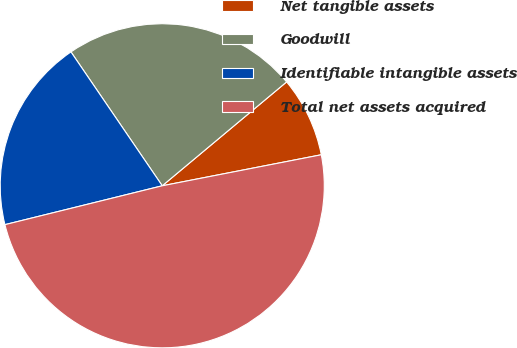Convert chart to OTSL. <chart><loc_0><loc_0><loc_500><loc_500><pie_chart><fcel>Net tangible assets<fcel>Goodwill<fcel>Identifiable intangible assets<fcel>Total net assets acquired<nl><fcel>8.01%<fcel>23.45%<fcel>19.33%<fcel>49.21%<nl></chart> 